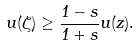Convert formula to latex. <formula><loc_0><loc_0><loc_500><loc_500>u ( \zeta ) \geq \frac { 1 - s } { 1 + s } u ( z ) .</formula> 